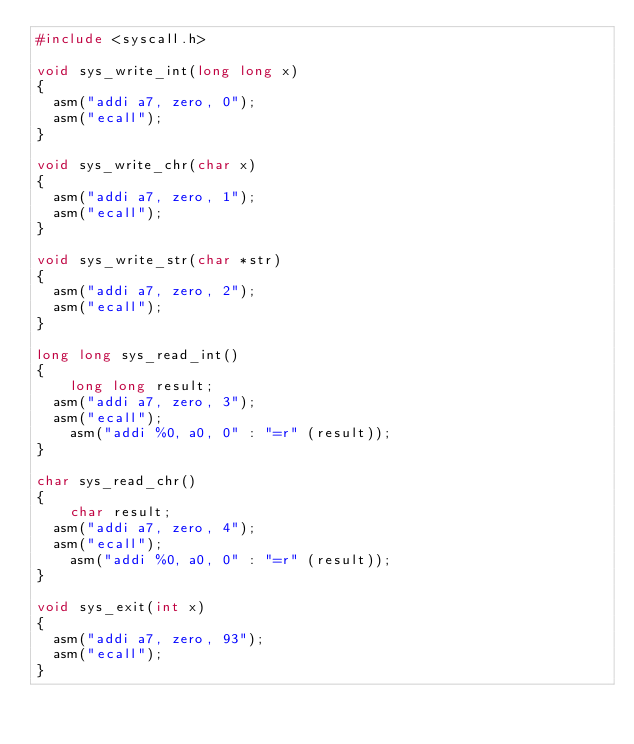Convert code to text. <code><loc_0><loc_0><loc_500><loc_500><_C_>#include <syscall.h>

void sys_write_int(long long x)
{
	asm("addi a7, zero, 0");
	asm("ecall");
}

void sys_write_chr(char x)
{
	asm("addi a7, zero, 1");
	asm("ecall");
}

void sys_write_str(char *str)
{
	asm("addi a7, zero, 2");
	asm("ecall");
}

long long sys_read_int()
{
    long long result;
	asm("addi a7, zero, 3");
	asm("ecall");
    asm("addi %0, a0, 0" : "=r" (result));
}

char sys_read_chr()
{
    char result;
	asm("addi a7, zero, 4");
	asm("ecall");
    asm("addi %0, a0, 0" : "=r" (result));
}

void sys_exit(int x)
{
	asm("addi a7, zero, 93");
	asm("ecall");
}
</code> 